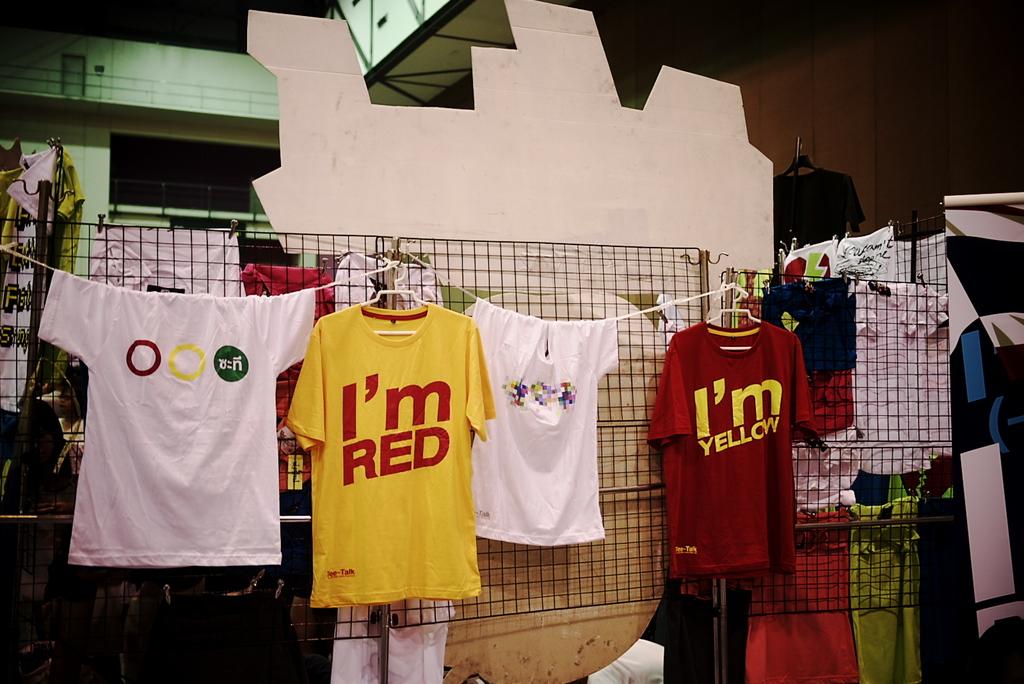What is the yellow shirt saying?
Make the answer very short. I'm red. What does the red shirt say?
Make the answer very short. I'm yellow. 